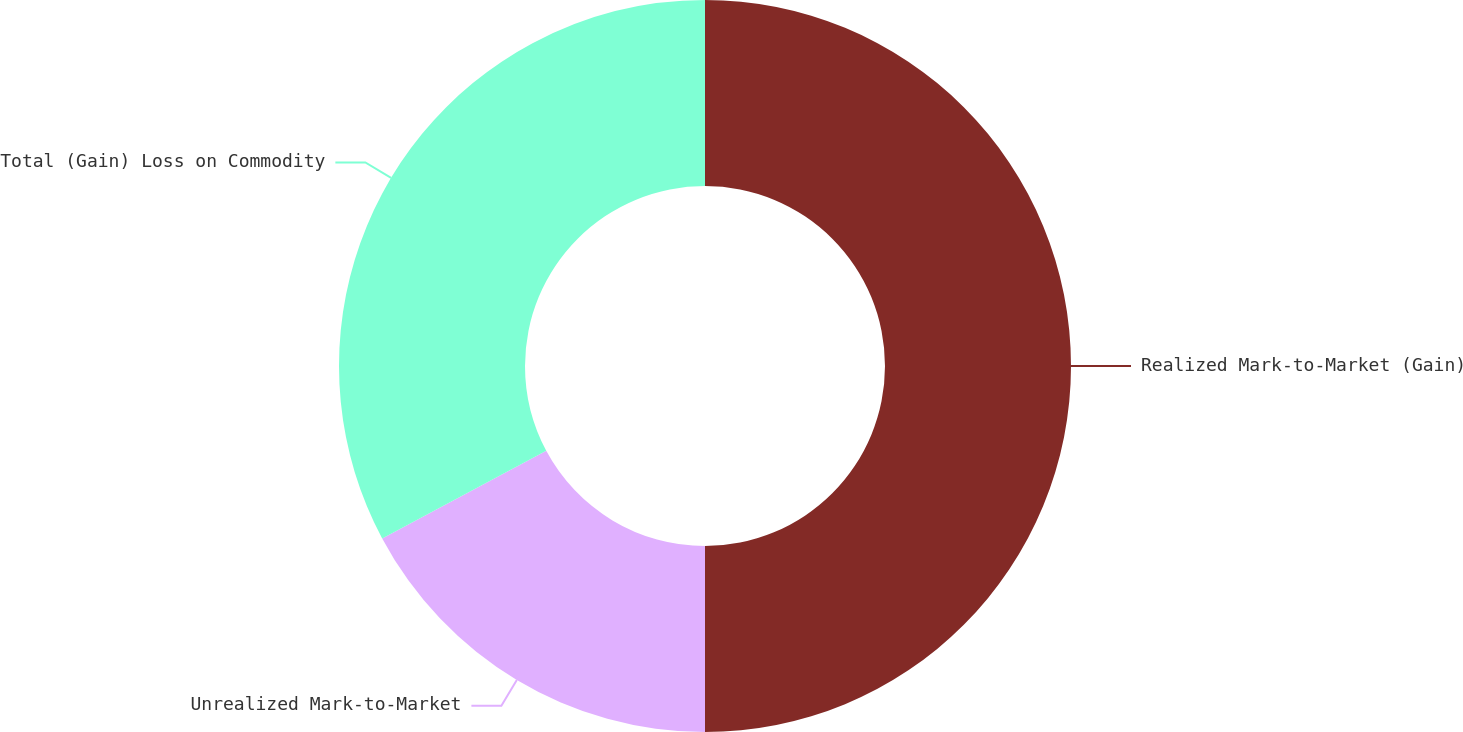Convert chart. <chart><loc_0><loc_0><loc_500><loc_500><pie_chart><fcel>Realized Mark-to-Market (Gain)<fcel>Unrealized Mark-to-Market<fcel>Total (Gain) Loss on Commodity<nl><fcel>50.0%<fcel>17.19%<fcel>32.81%<nl></chart> 